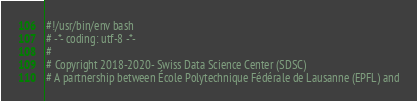Convert code to text. <code><loc_0><loc_0><loc_500><loc_500><_Bash_>#!/usr/bin/env bash
# -*- coding: utf-8 -*-
#
# Copyright 2018-2020- Swiss Data Science Center (SDSC)
# A partnership between École Polytechnique Fédérale de Lausanne (EPFL) and</code> 